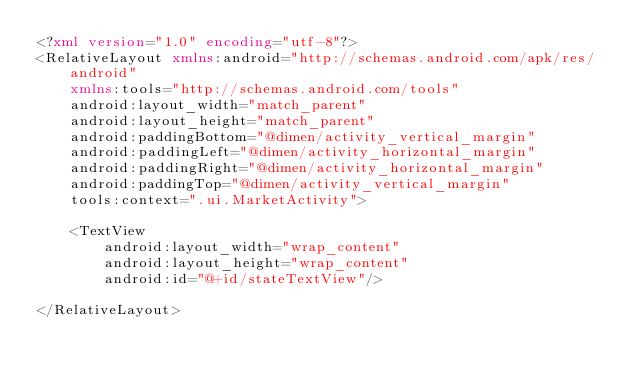<code> <loc_0><loc_0><loc_500><loc_500><_XML_><?xml version="1.0" encoding="utf-8"?>
<RelativeLayout xmlns:android="http://schemas.android.com/apk/res/android"
    xmlns:tools="http://schemas.android.com/tools"
    android:layout_width="match_parent"
    android:layout_height="match_parent"
    android:paddingBottom="@dimen/activity_vertical_margin"
    android:paddingLeft="@dimen/activity_horizontal_margin"
    android:paddingRight="@dimen/activity_horizontal_margin"
    android:paddingTop="@dimen/activity_vertical_margin"
    tools:context=".ui.MarketActivity">

    <TextView
        android:layout_width="wrap_content"
        android:layout_height="wrap_content"
        android:id="@+id/stateTextView"/>

</RelativeLayout>
</code> 